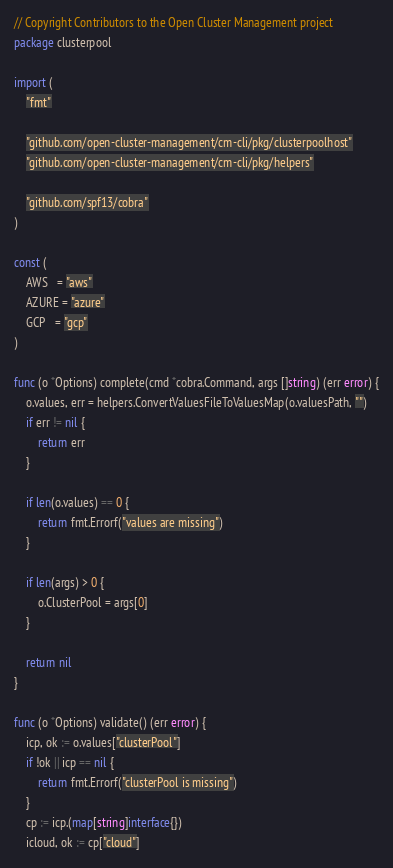<code> <loc_0><loc_0><loc_500><loc_500><_Go_>// Copyright Contributors to the Open Cluster Management project
package clusterpool

import (
	"fmt"

	"github.com/open-cluster-management/cm-cli/pkg/clusterpoolhost"
	"github.com/open-cluster-management/cm-cli/pkg/helpers"

	"github.com/spf13/cobra"
)

const (
	AWS   = "aws"
	AZURE = "azure"
	GCP   = "gcp"
)

func (o *Options) complete(cmd *cobra.Command, args []string) (err error) {
	o.values, err = helpers.ConvertValuesFileToValuesMap(o.valuesPath, "")
	if err != nil {
		return err
	}

	if len(o.values) == 0 {
		return fmt.Errorf("values are missing")
	}

	if len(args) > 0 {
		o.ClusterPool = args[0]
	}

	return nil
}

func (o *Options) validate() (err error) {
	icp, ok := o.values["clusterPool"]
	if !ok || icp == nil {
		return fmt.Errorf("clusterPool is missing")
	}
	cp := icp.(map[string]interface{})
	icloud, ok := cp["cloud"]</code> 